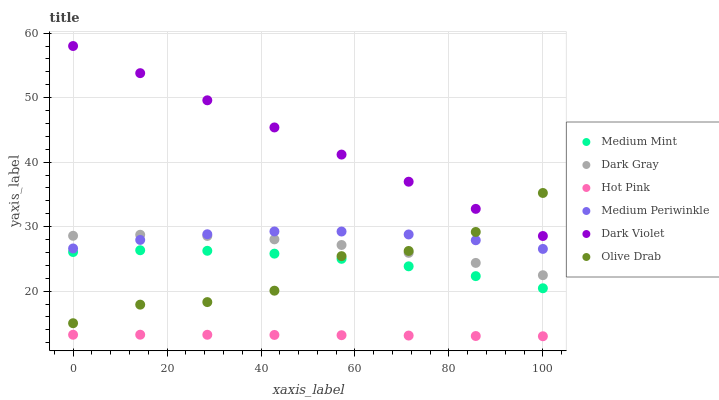Does Hot Pink have the minimum area under the curve?
Answer yes or no. Yes. Does Dark Violet have the maximum area under the curve?
Answer yes or no. Yes. Does Medium Periwinkle have the minimum area under the curve?
Answer yes or no. No. Does Medium Periwinkle have the maximum area under the curve?
Answer yes or no. No. Is Dark Violet the smoothest?
Answer yes or no. Yes. Is Olive Drab the roughest?
Answer yes or no. Yes. Is Hot Pink the smoothest?
Answer yes or no. No. Is Hot Pink the roughest?
Answer yes or no. No. Does Hot Pink have the lowest value?
Answer yes or no. Yes. Does Medium Periwinkle have the lowest value?
Answer yes or no. No. Does Dark Violet have the highest value?
Answer yes or no. Yes. Does Medium Periwinkle have the highest value?
Answer yes or no. No. Is Medium Mint less than Dark Gray?
Answer yes or no. Yes. Is Medium Mint greater than Hot Pink?
Answer yes or no. Yes. Does Olive Drab intersect Dark Gray?
Answer yes or no. Yes. Is Olive Drab less than Dark Gray?
Answer yes or no. No. Is Olive Drab greater than Dark Gray?
Answer yes or no. No. Does Medium Mint intersect Dark Gray?
Answer yes or no. No. 